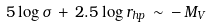Convert formula to latex. <formula><loc_0><loc_0><loc_500><loc_500>5 \log \sigma \, + \, 2 . 5 \log r _ { h p } \, \sim \, - \, M _ { V }</formula> 